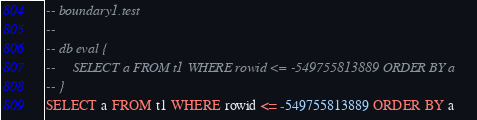<code> <loc_0><loc_0><loc_500><loc_500><_SQL_>-- boundary1.test
-- 
-- db eval {
--     SELECT a FROM t1 WHERE rowid <= -549755813889 ORDER BY a
-- }
SELECT a FROM t1 WHERE rowid <= -549755813889 ORDER BY a</code> 